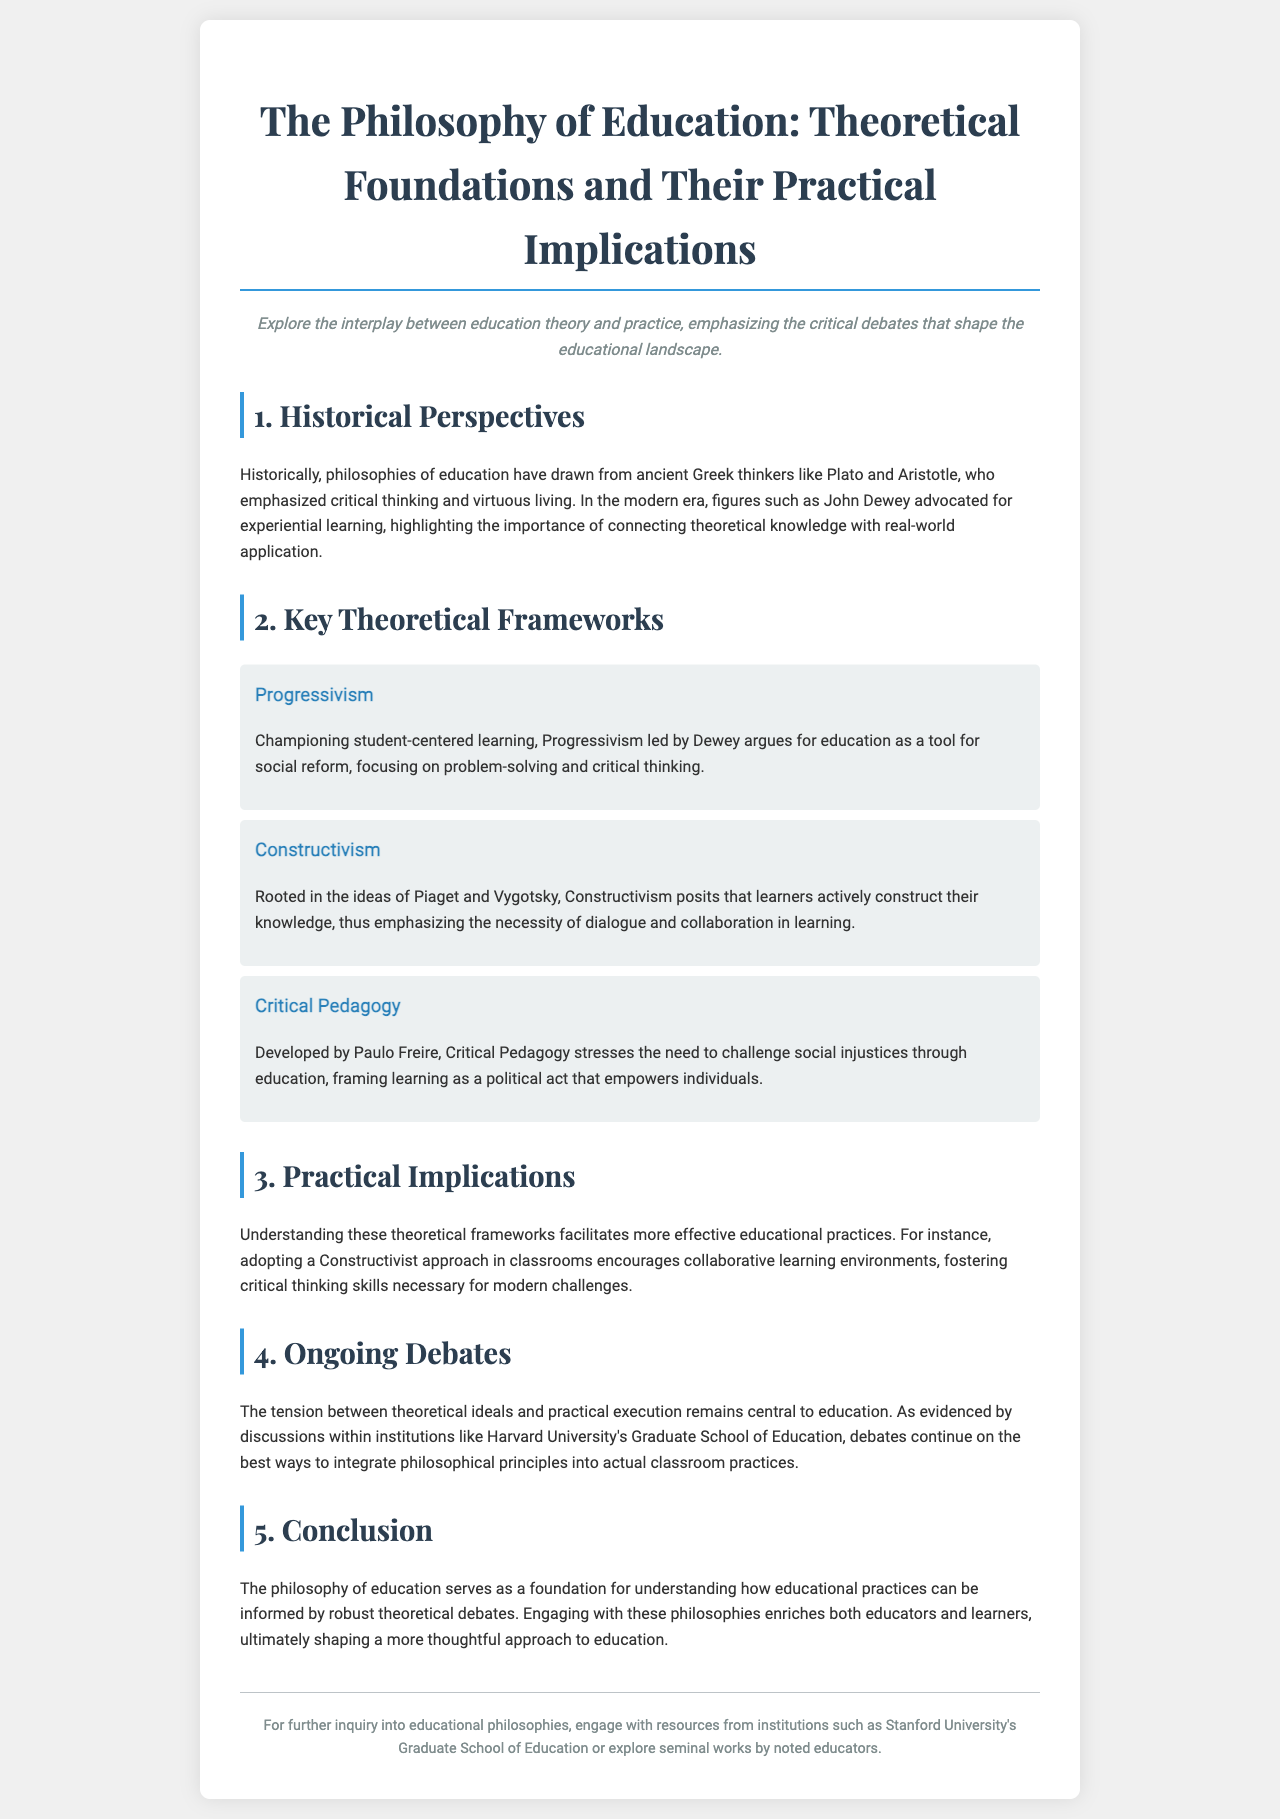What is the title of the brochure? The title of the brochure is prominently displayed at the top, stating the subject matter it covers.
Answer: The Philosophy of Education: Theoretical Foundations and Their Practical Implications Who were the ancient Greek thinkers mentioned? The document mentions Plato and Aristotle as key figures in historical perspectives on educational philosophy.
Answer: Plato and Aristotle What does Progressivism champion? Progressivism is described in the document as championing a specific approach to education that focuses on student-centered learning.
Answer: Student-centered learning Who developed Critical Pedagogy? The brochure attributes the development of Critical Pedagogy to a notable educator, making it an essential framework discussed.
Answer: Paulo Freire What is emphasized in Constructivism? The document indicates that Constructivism emphasizes a particular aspect of learning related to knowledge acquisition.
Answer: Collaborative learning What ongoing debates are mentioned? The document notes a specific area where discussions continue regarding educational practices and philosophical principles.
Answer: Integration of philosophical principles into actual classroom practices What is the practical implication of understanding theoretical frameworks? The brochure highlights a specific benefit that comes from comprehending theoretical frameworks in education.
Answer: More effective educational practices Which institution is cited for ongoing debates? The document references a prominent institution that engages in discussions around educational principles and practices.
Answer: Harvard University's Graduate School of Education 